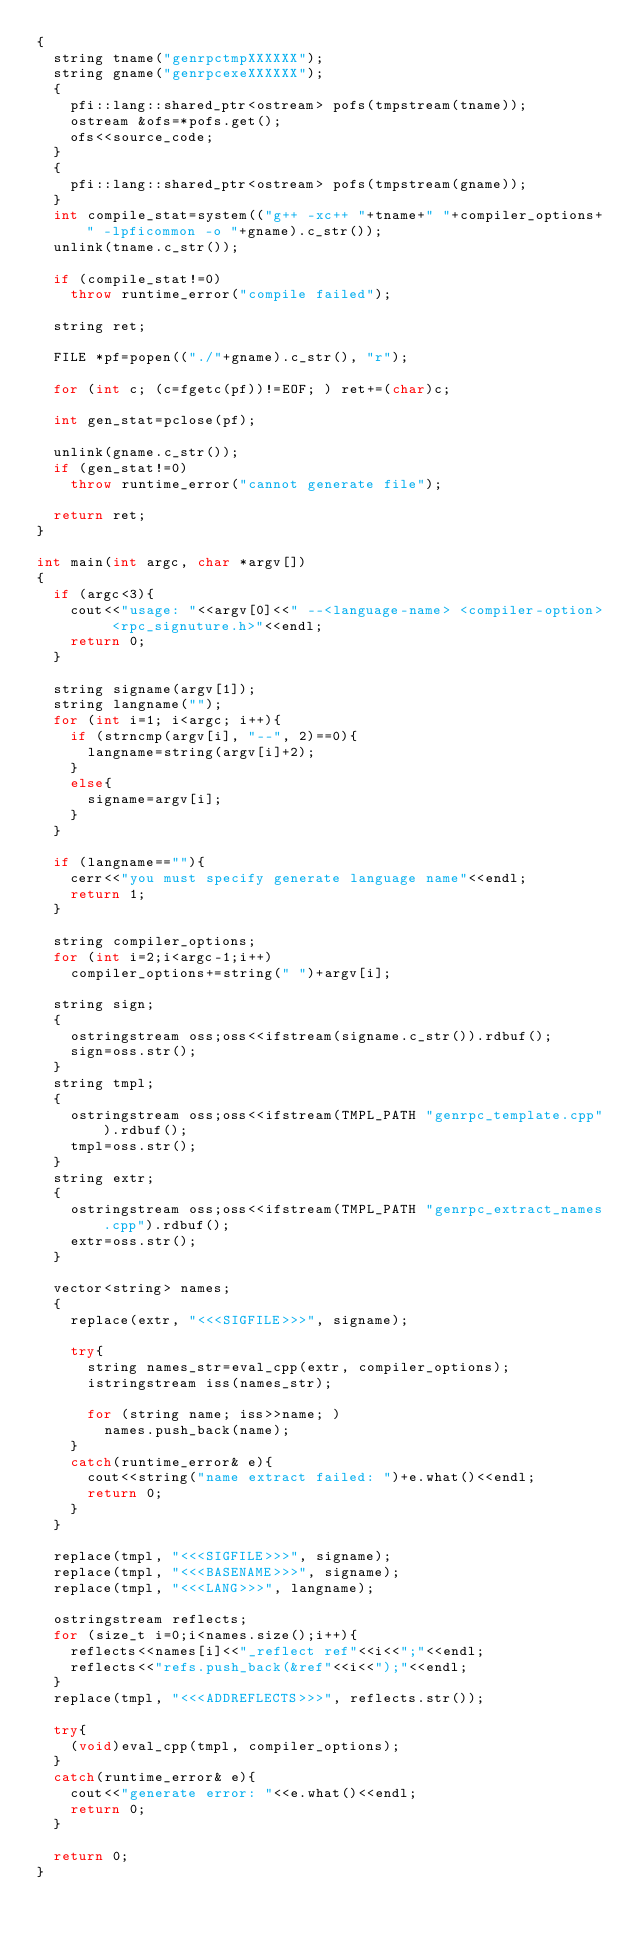Convert code to text. <code><loc_0><loc_0><loc_500><loc_500><_C++_>{
  string tname("genrpctmpXXXXXX");
  string gname("genrpcexeXXXXXX");
  {
    pfi::lang::shared_ptr<ostream> pofs(tmpstream(tname));
    ostream &ofs=*pofs.get();
    ofs<<source_code;
  }
  {
    pfi::lang::shared_ptr<ostream> pofs(tmpstream(gname));
  }
  int compile_stat=system(("g++ -xc++ "+tname+" "+compiler_options+" -lpficommon -o "+gname).c_str());
  unlink(tname.c_str());
  
  if (compile_stat!=0)
    throw runtime_error("compile failed");
  
  string ret;

  FILE *pf=popen(("./"+gname).c_str(), "r");

  for (int c; (c=fgetc(pf))!=EOF; ) ret+=(char)c;

  int gen_stat=pclose(pf);

  unlink(gname.c_str());
  if (gen_stat!=0)
    throw runtime_error("cannot generate file");

  return ret;
}

int main(int argc, char *argv[])
{
  if (argc<3){
    cout<<"usage: "<<argv[0]<<" --<language-name> <compiler-option> <rpc_signuture.h>"<<endl;
    return 0;
  }

  string signame(argv[1]);
  string langname("");
  for (int i=1; i<argc; i++){
    if (strncmp(argv[i], "--", 2)==0){
      langname=string(argv[i]+2);
    }
    else{
      signame=argv[i];
    }
  }

  if (langname==""){
    cerr<<"you must specify generate language name"<<endl;
    return 1;
  }

  string compiler_options;
  for (int i=2;i<argc-1;i++)
    compiler_options+=string(" ")+argv[i];

  string sign;
  {
    ostringstream oss;oss<<ifstream(signame.c_str()).rdbuf();
    sign=oss.str();
  }
  string tmpl;
  {
    ostringstream oss;oss<<ifstream(TMPL_PATH "genrpc_template.cpp").rdbuf();
    tmpl=oss.str();
  }
  string extr;
  {
    ostringstream oss;oss<<ifstream(TMPL_PATH "genrpc_extract_names.cpp").rdbuf();
    extr=oss.str();
  }

  vector<string> names;
  {
    replace(extr, "<<<SIGFILE>>>", signame);

    try{
      string names_str=eval_cpp(extr, compiler_options);
      istringstream iss(names_str);
      
      for (string name; iss>>name; )
        names.push_back(name);
    }
    catch(runtime_error& e){
      cout<<string("name extract failed: ")+e.what()<<endl;
      return 0;
    }
  }

  replace(tmpl, "<<<SIGFILE>>>", signame);
  replace(tmpl, "<<<BASENAME>>>", signame);
  replace(tmpl, "<<<LANG>>>", langname);

  ostringstream reflects;
  for (size_t i=0;i<names.size();i++){
    reflects<<names[i]<<"_reflect ref"<<i<<";"<<endl;
    reflects<<"refs.push_back(&ref"<<i<<");"<<endl;
  }
  replace(tmpl, "<<<ADDREFLECTS>>>", reflects.str());

  try{
    (void)eval_cpp(tmpl, compiler_options);
  }
  catch(runtime_error& e){
    cout<<"generate error: "<<e.what()<<endl;
    return 0;
  }

  return 0;
}
</code> 